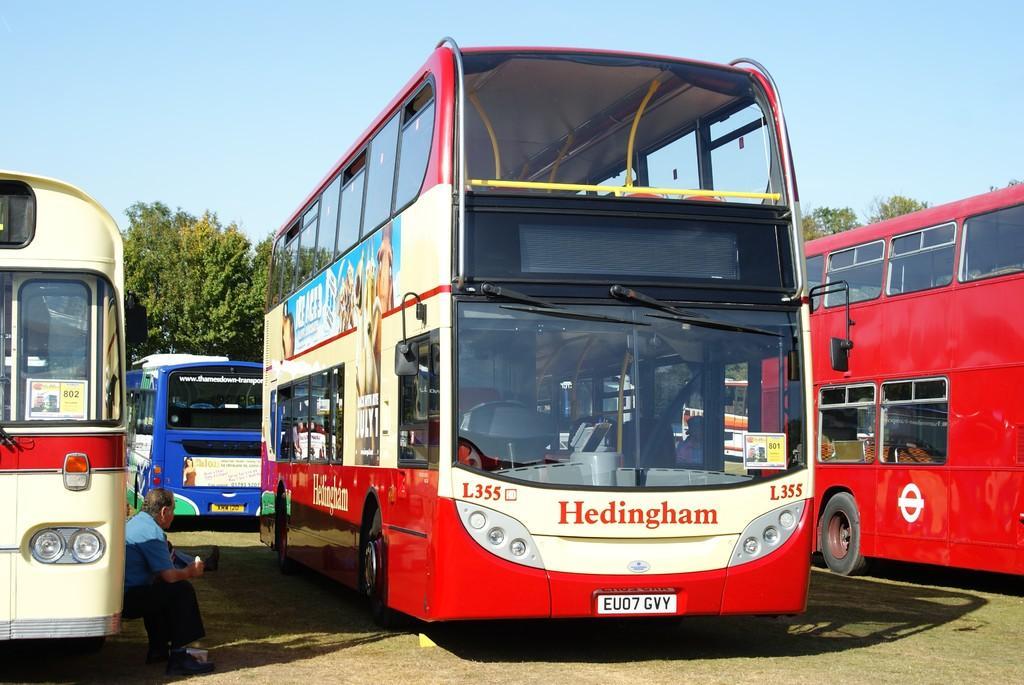Could you give a brief overview of what you see in this image? In this image we can see four buses. In the background, we can see trees. At the top of the image, we can see the sky. At the bottom of the image, we can see the land. On the left side of the image, we can see a man. 